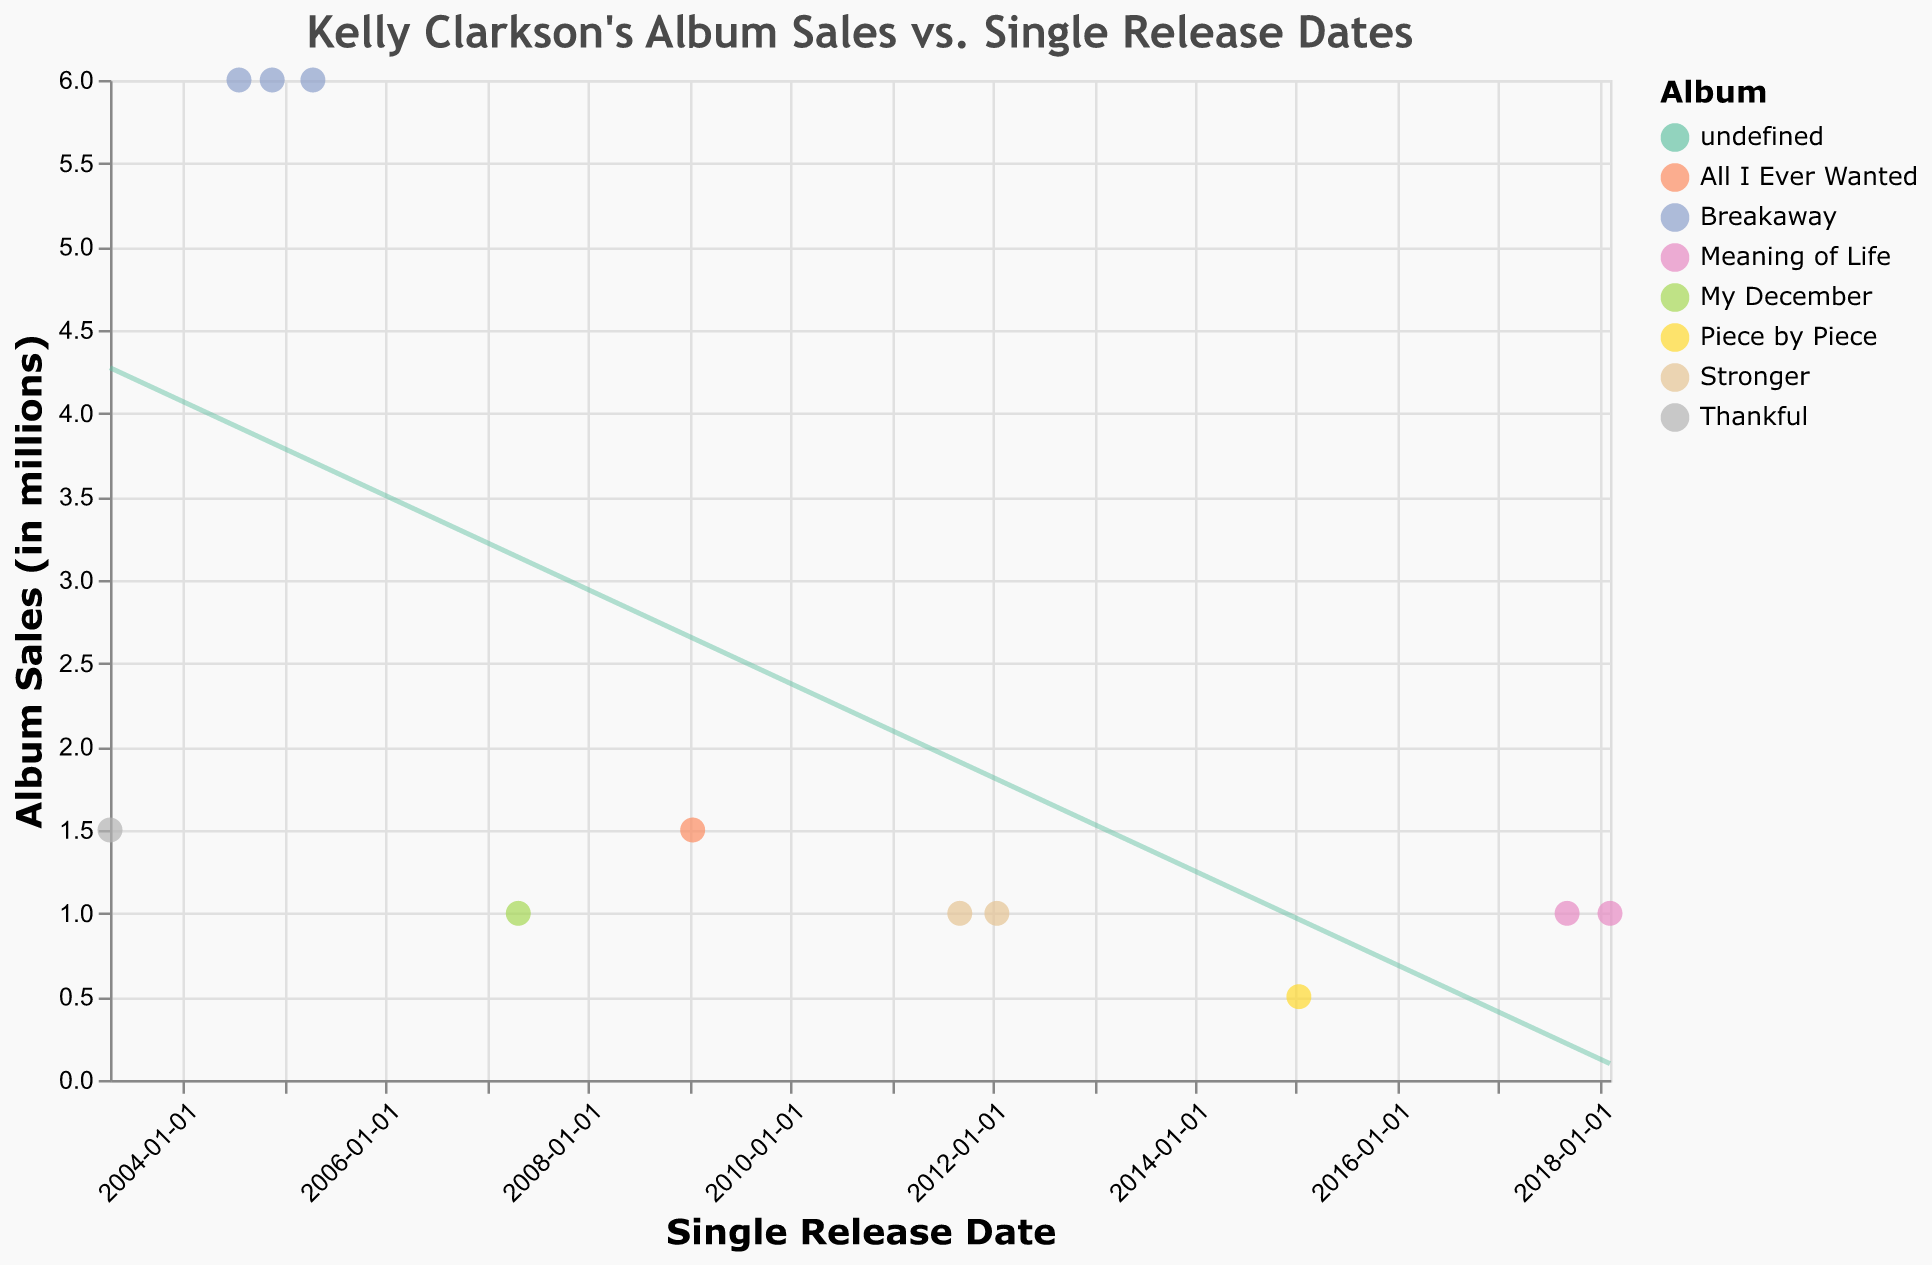What's the title of the plot? The title is displayed prominently at the top center of the plot.
Answer: Kelly Clarkson's Album Sales vs. Single Release Dates How many albums are represented in the plot? There are different colors for each album represented on the plot, and the legend indicates the names of the albums. Count the unique album titles in the legend.
Answer: 6 Which single has the highest album sales associated with it? Look for the highest point on the y-axis and note the associated single from the tooltip or legend.
Answer: Since U Been Gone On which date did the single "Stronger (What Doesn't Kill You)" release, and what were the associated album sales? Check the position of "Stronger (What Doesn't Kill You)" on the x-axis. The tooltip will show its release date and the y-axis will show the associated album sales.
Answer: 2012-01-17, 1.0 million How does the album "Breakaway" compare to other albums in terms of sales? Look at the data points associated with "Breakaway" and compare their positions on the y-axis to the data points of other albums.
Answer: "Breakaway" has consistently higher sales (6.0 million) than the other albums What's the trend between single release dates and album sales? Analyze the red trend line that shows the overall pattern. Note the slope and direction of the line to explain the trend.
Answer: Negative trend, sales tend to decrease over time Which album has the lowest sales and for which single? Identify the lowest point on the y-axis and cross-reference the album and single using the tooltip.
Answer: Piece by Piece, Heartbeat Song Calculate the average album sales across all singles. Sum the album sales for all singles and divide by the number of singles. (1.5+6.0+6.0+6.0+1.0+1.5+1.0+1.0+0.5+1.0+1.0)/11 = 27.5/11
Answer: 2.5 million Compare the release date and sales for "Miss Independent" and "Love So Soft". Which had higher sales? Identify "Miss Independent" and "Love So Soft" on the plot, compare their y-axis positions to determine which had higher sales.
Answer: Miss Independent had higher sales (1.5 million vs. 1.0 million) What does the color of each data point represent? Refer to the legend at the side or top of the plot which explains what each color represents.
Answer: Each color represents a different album 